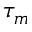Convert formula to latex. <formula><loc_0><loc_0><loc_500><loc_500>\tau _ { m }</formula> 